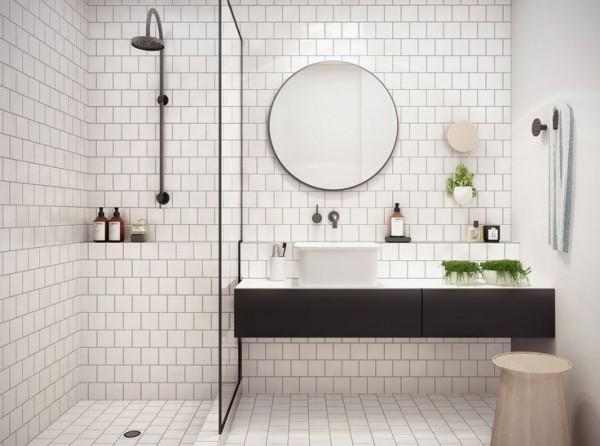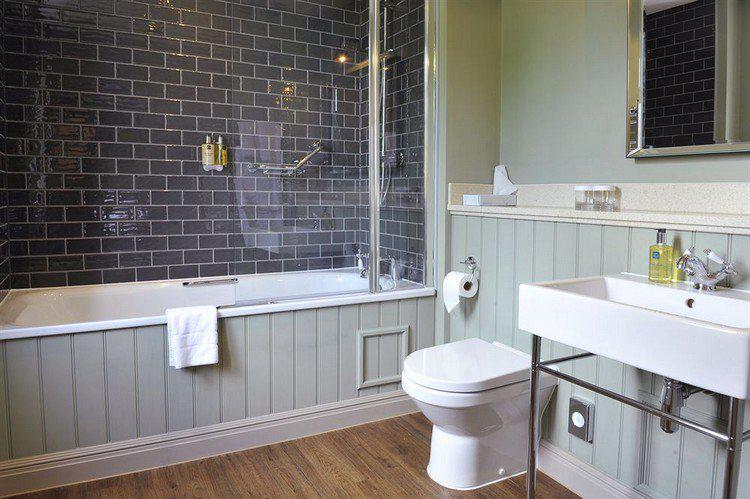The first image is the image on the left, the second image is the image on the right. Examine the images to the left and right. Is the description "One bathroom has a squarish mirror above a rectangular white sink and dark tile arranged like brick in the shower area." accurate? Answer yes or no. Yes. 